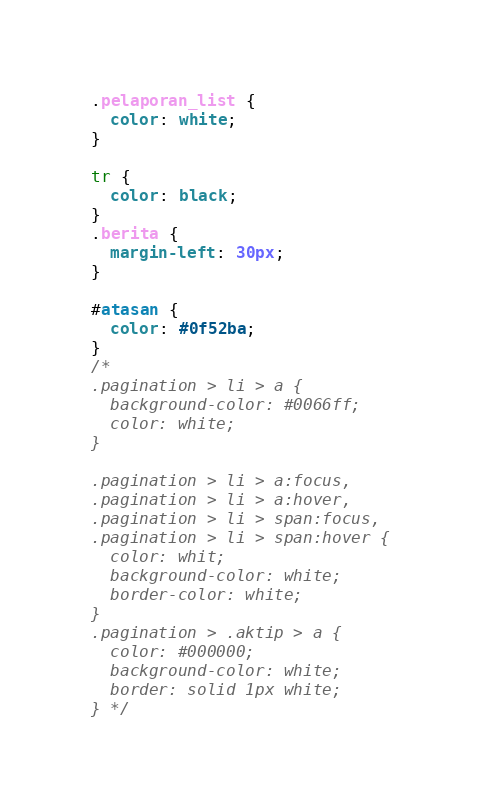<code> <loc_0><loc_0><loc_500><loc_500><_CSS_>.pelaporan_list {
  color: white;
}

tr {
  color: black;
}
.berita {
  margin-left: 30px;
}

#atasan {
  color: #0f52ba;
}
/* 
.pagination > li > a {
  background-color: #0066ff;
  color: white;
}

.pagination > li > a:focus,
.pagination > li > a:hover,
.pagination > li > span:focus,
.pagination > li > span:hover {
  color: whit;
  background-color: white;
  border-color: white;
}
.pagination > .aktip > a {
  color: #000000;
  background-color: white;
  border: solid 1px white;
} */
</code> 